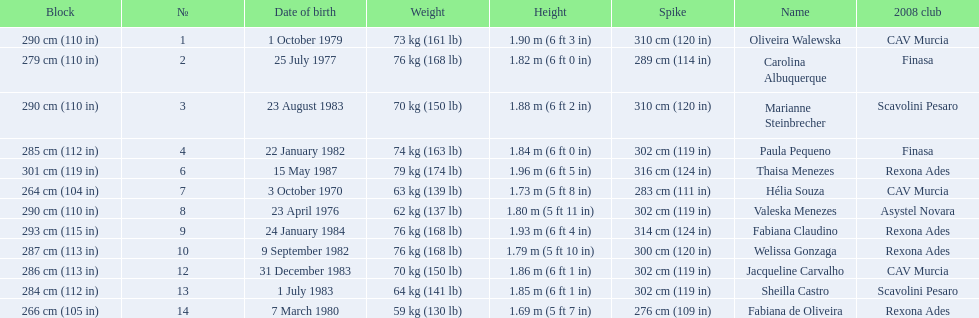What are the heights of the players? 1.90 m (6 ft 3 in), 1.82 m (6 ft 0 in), 1.88 m (6 ft 2 in), 1.84 m (6 ft 0 in), 1.96 m (6 ft 5 in), 1.73 m (5 ft 8 in), 1.80 m (5 ft 11 in), 1.93 m (6 ft 4 in), 1.79 m (5 ft 10 in), 1.86 m (6 ft 1 in), 1.85 m (6 ft 1 in), 1.69 m (5 ft 7 in). Which of these heights is the shortest? 1.69 m (5 ft 7 in). Which player is 5'7 tall? Fabiana de Oliveira. 